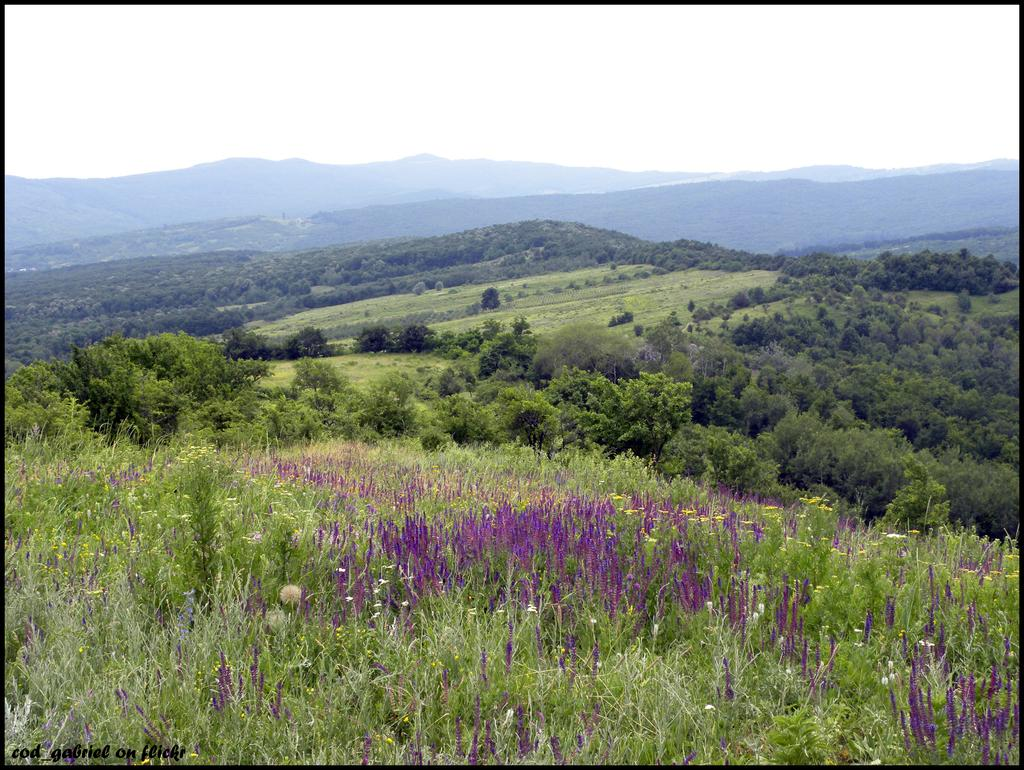What type of view is shown in the image? The image is an outside view. What can be seen at the bottom of the image? There are many plants with flowers at the bottom of the image. What is visible in the background of the image? There are trees and hills in the background of the image. What is visible at the top of the image? The sky is visible at the top of the image. How many clocks are hanging from the trees in the image? There are no clocks hanging from the trees in the image. What type of cloud is present in the image? There is no cloud present in the image; it only shows plants, trees, hills, and the sky. 